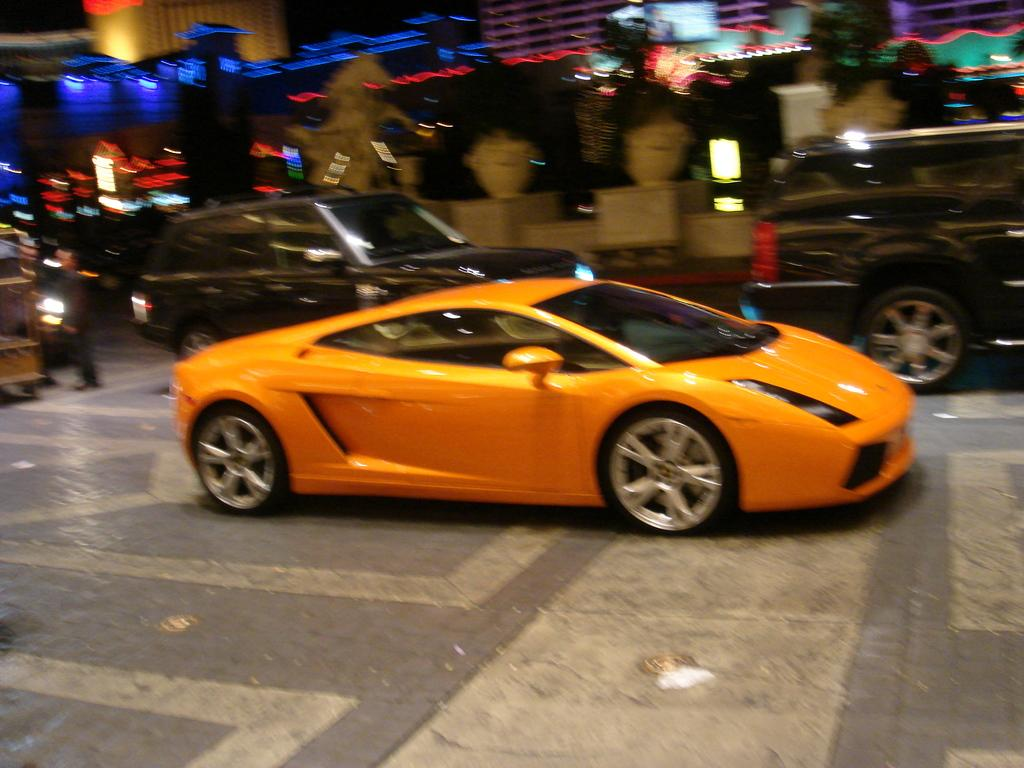What is the main subject of the image? The main subject of the image is a car. What is the car doing in the image? The car is moving on the road in the image. What is the color of the car? The car is orange in color. What else can be seen in the image besides the car? There are buildings in the image. What feature of the buildings is mentioned in the facts? The buildings have lights. Can you tell me how many drawers are in the car? There are no drawers present in the car or the image. What is the health status of the car in the image? The facts provided do not mention the health status of the car, only its color and action. 